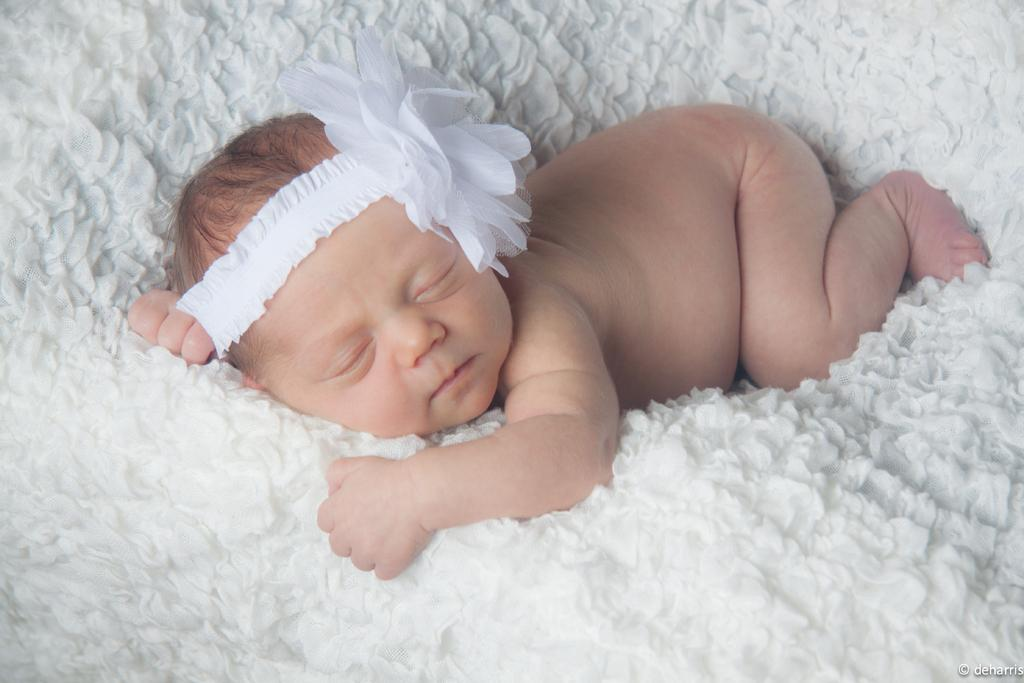What is the main subject of the image? There is a baby in the image. Where is the baby located? The baby is lying on a white color couch. What is on the baby's head? There is a white color thing on the baby's head. What is the opinion of the jellyfish committee about the baby's outfit in the image? There is no jellyfish committee present in the image, and therefore no opinion can be given about the baby's outfit. 